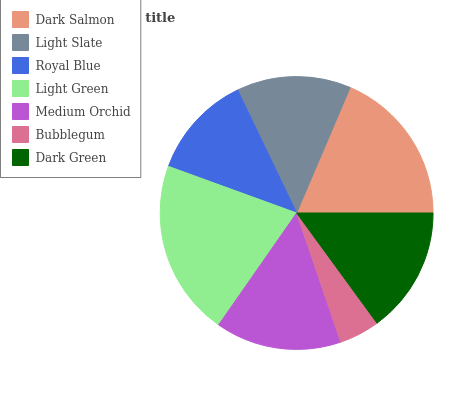Is Bubblegum the minimum?
Answer yes or no. Yes. Is Light Green the maximum?
Answer yes or no. Yes. Is Light Slate the minimum?
Answer yes or no. No. Is Light Slate the maximum?
Answer yes or no. No. Is Dark Salmon greater than Light Slate?
Answer yes or no. Yes. Is Light Slate less than Dark Salmon?
Answer yes or no. Yes. Is Light Slate greater than Dark Salmon?
Answer yes or no. No. Is Dark Salmon less than Light Slate?
Answer yes or no. No. Is Medium Orchid the high median?
Answer yes or no. Yes. Is Medium Orchid the low median?
Answer yes or no. Yes. Is Royal Blue the high median?
Answer yes or no. No. Is Light Slate the low median?
Answer yes or no. No. 